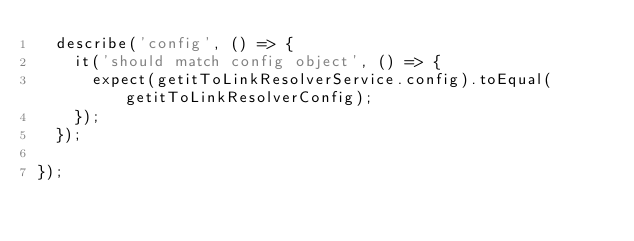<code> <loc_0><loc_0><loc_500><loc_500><_JavaScript_>  describe('config', () => {
    it('should match config object', () => {
      expect(getitToLinkResolverService.config).toEqual(getitToLinkResolverConfig);
    });
  });

});
</code> 